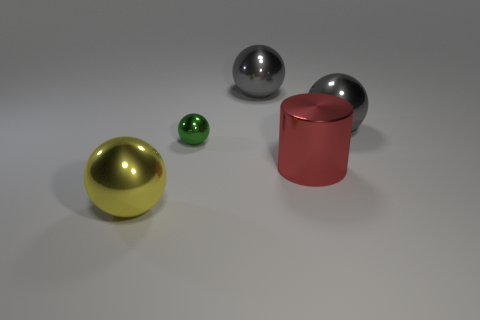The gray object that is on the left side of the large gray ball that is on the right side of the large red metal cylinder in front of the small green object is made of what material? metal 